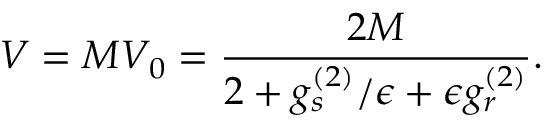<formula> <loc_0><loc_0><loc_500><loc_500>V = M V _ { 0 } = \frac { 2 M } { 2 + g _ { s } ^ { ( 2 ) } / \epsilon + \epsilon g _ { r } ^ { ( 2 ) } } .</formula> 